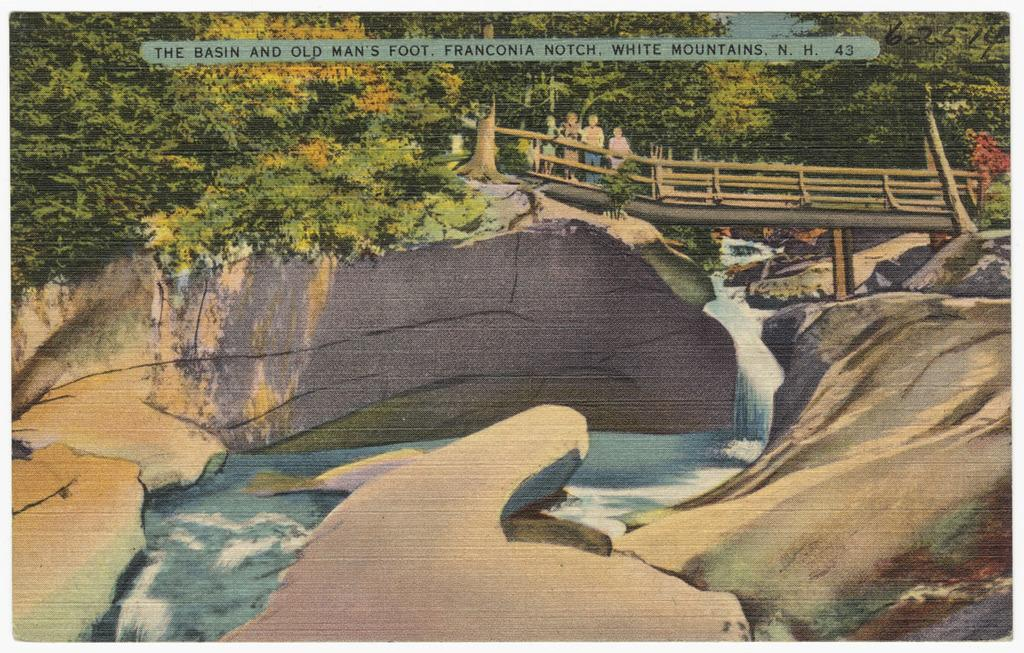What is the main subject of the image? The image contains a painting. What is happening in the painting? The painting depicts a group of persons standing on a bridge. What natural elements are present in the painting? Water and a group of trees are present in the painting. Are there any words or letters in the painting? Yes, there is some text in the painting. How many kittens can be seen playing in the water in the painting? There are no kittens present in the painting; it depicts a group of persons standing on a bridge. Is there a donkey visible in the group of trees in the painting? There is no donkey present in the painting; it only features a group of trees. 